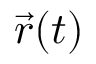<formula> <loc_0><loc_0><loc_500><loc_500>{ \vec { r } } ( t )</formula> 